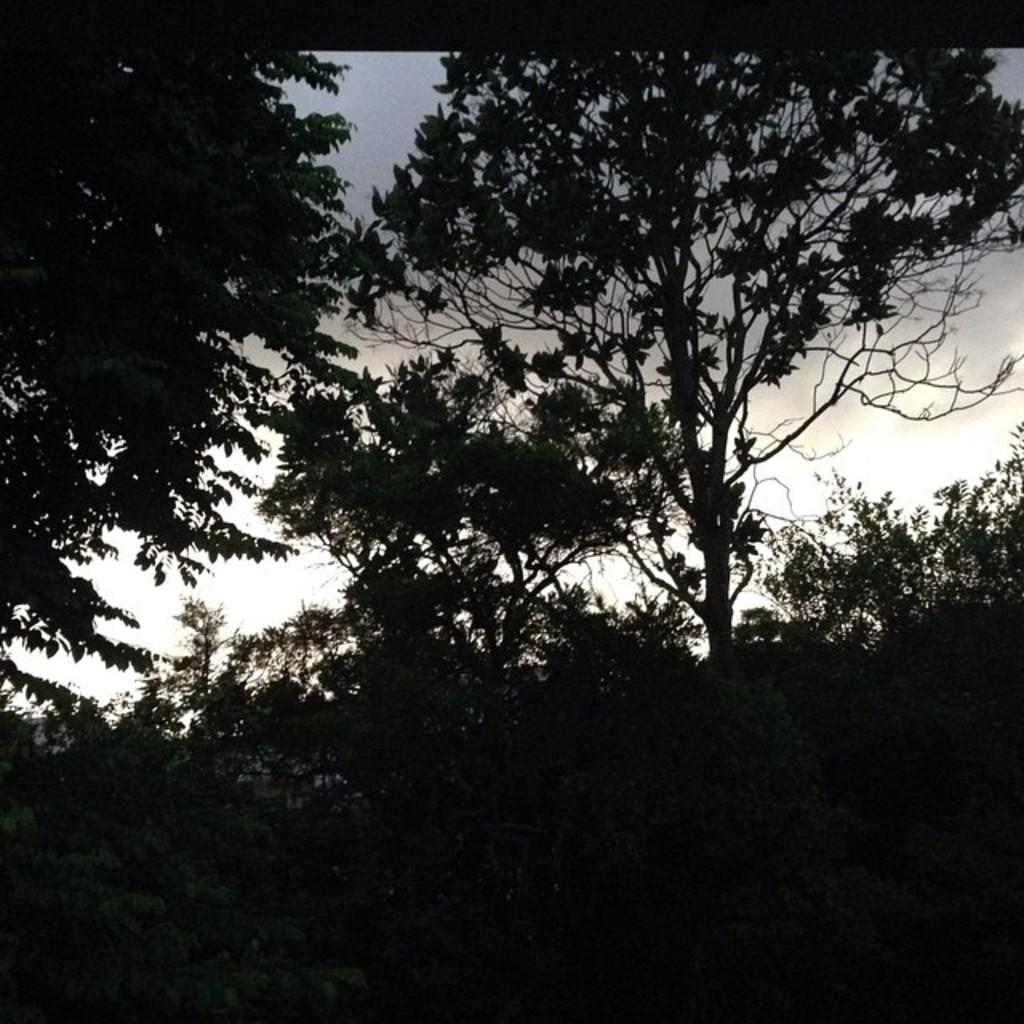What type of vegetation can be seen in the image? There are trees in the image. What is the color of the sky in the background of the image? The sky is white in color in the background of the image. Where is the school located in the image? There is no school present in the image. What type of seasoning is visible in the image? There is no salt present in the image. What type of adhesive is being used in the image? There is no glue present in the image. 